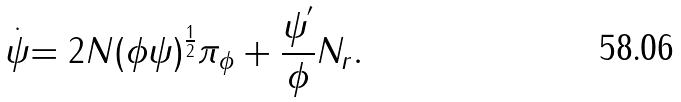Convert formula to latex. <formula><loc_0><loc_0><loc_500><loc_500>\stackrel { . } { \psi } = 2 N ( \phi \psi ) ^ { \frac { 1 } { 2 } } \pi _ { \phi } + \frac { \psi ^ { ^ { \prime } } } { \phi } N _ { r } .</formula> 